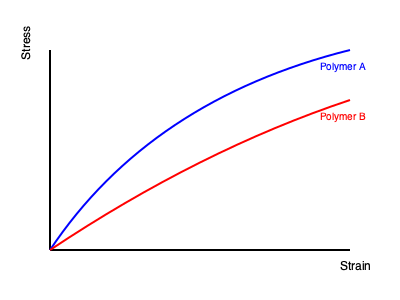Compare the stress-strain curves of two biodegradable polymers (A and B) shown in the graph. Which polymer would be more suitable for an application requiring high flexibility and toughness in sustainable packaging? Justify your answer based on the mechanical properties inferred from the curves. To determine which polymer is more suitable for flexible and tough sustainable packaging, we need to analyze the stress-strain curves:

1. Flexibility: This is related to the initial slope of the curve (Young's modulus). A lower slope indicates higher flexibility.
   - Polymer A has a lower initial slope than Polymer B, indicating higher flexibility.

2. Toughness: This is represented by the area under the stress-strain curve. A larger area indicates higher toughness.
   - Polymer A has a larger area under its curve compared to Polymer B, suggesting higher toughness.

3. Elongation at break: This is the maximum strain before failure. Higher elongation indicates better stretchability.
   - Polymer A shows a higher maximum strain than Polymer B, indicating better stretchability.

4. Ultimate strength: This is the maximum stress the material can withstand.
   - Polymer A has a lower ultimate strength compared to Polymer B, but this may not be crucial for packaging applications.

5. Sustainability: Both polymers are described as biodegradable, meeting the sustainability requirement.

Considering these factors, Polymer A demonstrates higher flexibility, toughness, and stretchability, which are crucial properties for flexible packaging materials. While it has lower ultimate strength, this trade-off is acceptable for packaging applications that prioritize flexibility and toughness over high strength.
Answer: Polymer A, due to higher flexibility, toughness, and elongation at break. 